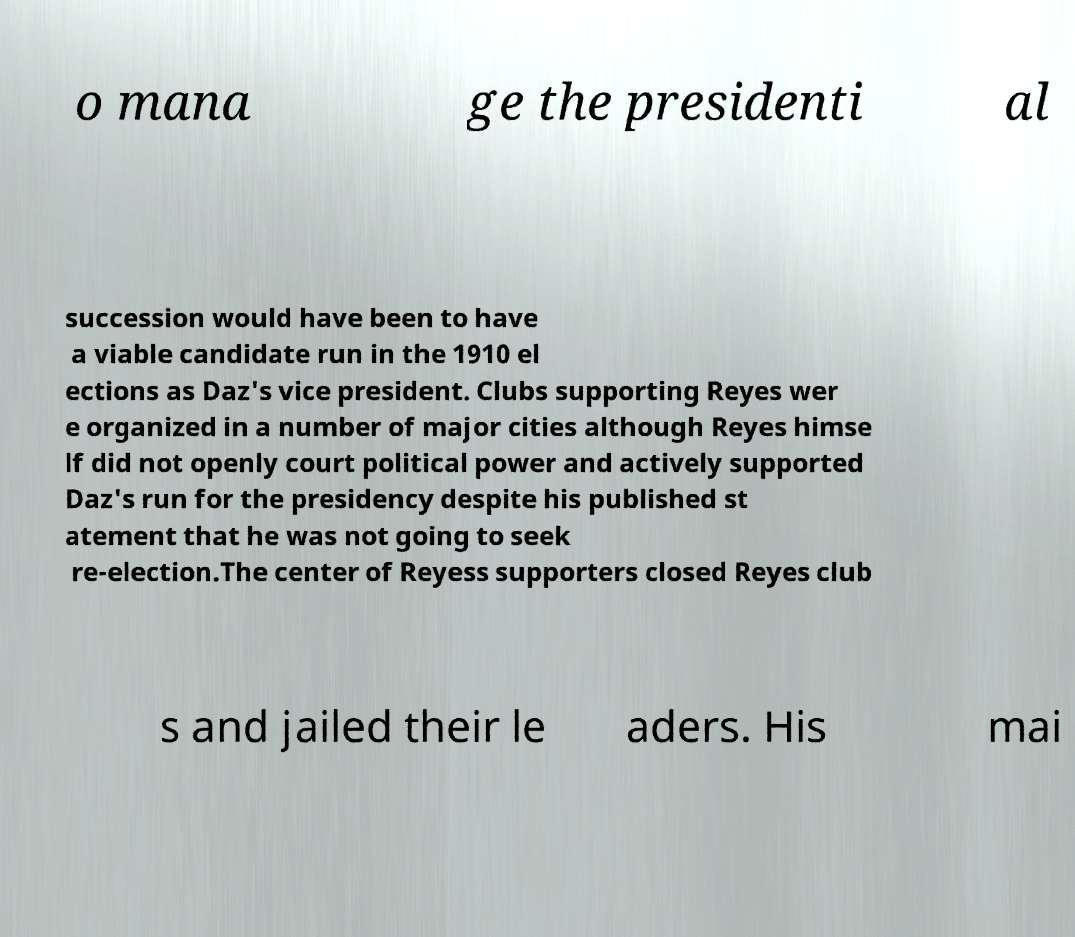Can you accurately transcribe the text from the provided image for me? o mana ge the presidenti al succession would have been to have a viable candidate run in the 1910 el ections as Daz's vice president. Clubs supporting Reyes wer e organized in a number of major cities although Reyes himse lf did not openly court political power and actively supported Daz's run for the presidency despite his published st atement that he was not going to seek re-election.The center of Reyess supporters closed Reyes club s and jailed their le aders. His mai 